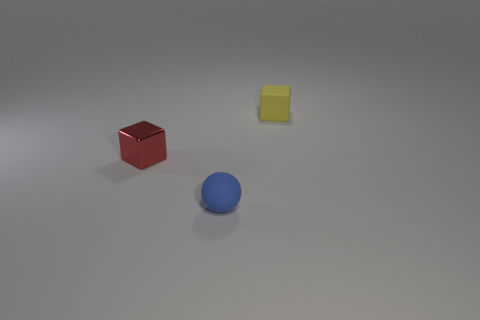Add 2 large gray rubber cylinders. How many objects exist? 5 Subtract all balls. How many objects are left? 2 Subtract 1 cubes. How many cubes are left? 1 Subtract all blue spheres. How many red blocks are left? 1 Subtract 0 green blocks. How many objects are left? 3 Subtract all purple cubes. Subtract all brown cylinders. How many cubes are left? 2 Subtract all purple shiny things. Subtract all small matte objects. How many objects are left? 1 Add 3 small matte objects. How many small matte objects are left? 5 Add 1 small metallic spheres. How many small metallic spheres exist? 1 